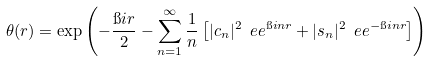<formula> <loc_0><loc_0><loc_500><loc_500>\theta ( r ) = \exp \left ( - \frac { \i i r } 2 - \sum _ { n = 1 } ^ { \infty } \frac { 1 } { n } \left [ | c _ { n } | ^ { 2 } \ e e ^ { \i i n r } + | s _ { n } | ^ { 2 } \ e e ^ { - \i i n r } \right ] \right )</formula> 